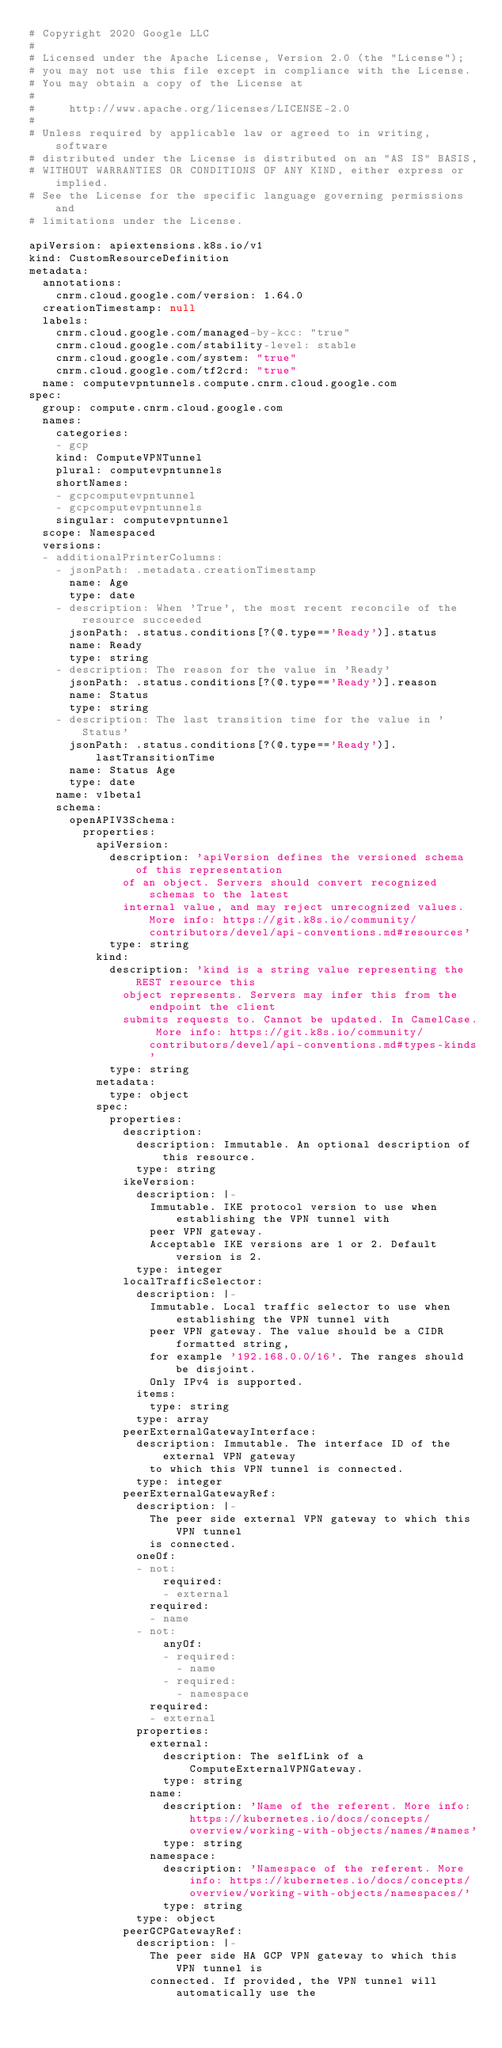<code> <loc_0><loc_0><loc_500><loc_500><_YAML_># Copyright 2020 Google LLC
#
# Licensed under the Apache License, Version 2.0 (the "License");
# you may not use this file except in compliance with the License.
# You may obtain a copy of the License at
#
#     http://www.apache.org/licenses/LICENSE-2.0
#
# Unless required by applicable law or agreed to in writing, software
# distributed under the License is distributed on an "AS IS" BASIS,
# WITHOUT WARRANTIES OR CONDITIONS OF ANY KIND, either express or implied.
# See the License for the specific language governing permissions and
# limitations under the License.

apiVersion: apiextensions.k8s.io/v1
kind: CustomResourceDefinition
metadata:
  annotations:
    cnrm.cloud.google.com/version: 1.64.0
  creationTimestamp: null
  labels:
    cnrm.cloud.google.com/managed-by-kcc: "true"
    cnrm.cloud.google.com/stability-level: stable
    cnrm.cloud.google.com/system: "true"
    cnrm.cloud.google.com/tf2crd: "true"
  name: computevpntunnels.compute.cnrm.cloud.google.com
spec:
  group: compute.cnrm.cloud.google.com
  names:
    categories:
    - gcp
    kind: ComputeVPNTunnel
    plural: computevpntunnels
    shortNames:
    - gcpcomputevpntunnel
    - gcpcomputevpntunnels
    singular: computevpntunnel
  scope: Namespaced
  versions:
  - additionalPrinterColumns:
    - jsonPath: .metadata.creationTimestamp
      name: Age
      type: date
    - description: When 'True', the most recent reconcile of the resource succeeded
      jsonPath: .status.conditions[?(@.type=='Ready')].status
      name: Ready
      type: string
    - description: The reason for the value in 'Ready'
      jsonPath: .status.conditions[?(@.type=='Ready')].reason
      name: Status
      type: string
    - description: The last transition time for the value in 'Status'
      jsonPath: .status.conditions[?(@.type=='Ready')].lastTransitionTime
      name: Status Age
      type: date
    name: v1beta1
    schema:
      openAPIV3Schema:
        properties:
          apiVersion:
            description: 'apiVersion defines the versioned schema of this representation
              of an object. Servers should convert recognized schemas to the latest
              internal value, and may reject unrecognized values. More info: https://git.k8s.io/community/contributors/devel/api-conventions.md#resources'
            type: string
          kind:
            description: 'kind is a string value representing the REST resource this
              object represents. Servers may infer this from the endpoint the client
              submits requests to. Cannot be updated. In CamelCase. More info: https://git.k8s.io/community/contributors/devel/api-conventions.md#types-kinds'
            type: string
          metadata:
            type: object
          spec:
            properties:
              description:
                description: Immutable. An optional description of this resource.
                type: string
              ikeVersion:
                description: |-
                  Immutable. IKE protocol version to use when establishing the VPN tunnel with
                  peer VPN gateway.
                  Acceptable IKE versions are 1 or 2. Default version is 2.
                type: integer
              localTrafficSelector:
                description: |-
                  Immutable. Local traffic selector to use when establishing the VPN tunnel with
                  peer VPN gateway. The value should be a CIDR formatted string,
                  for example '192.168.0.0/16'. The ranges should be disjoint.
                  Only IPv4 is supported.
                items:
                  type: string
                type: array
              peerExternalGatewayInterface:
                description: Immutable. The interface ID of the external VPN gateway
                  to which this VPN tunnel is connected.
                type: integer
              peerExternalGatewayRef:
                description: |-
                  The peer side external VPN gateway to which this VPN tunnel
                  is connected.
                oneOf:
                - not:
                    required:
                    - external
                  required:
                  - name
                - not:
                    anyOf:
                    - required:
                      - name
                    - required:
                      - namespace
                  required:
                  - external
                properties:
                  external:
                    description: The selfLink of a ComputeExternalVPNGateway.
                    type: string
                  name:
                    description: 'Name of the referent. More info: https://kubernetes.io/docs/concepts/overview/working-with-objects/names/#names'
                    type: string
                  namespace:
                    description: 'Namespace of the referent. More info: https://kubernetes.io/docs/concepts/overview/working-with-objects/namespaces/'
                    type: string
                type: object
              peerGCPGatewayRef:
                description: |-
                  The peer side HA GCP VPN gateway to which this VPN tunnel is
                  connected. If provided, the VPN tunnel will automatically use the</code> 